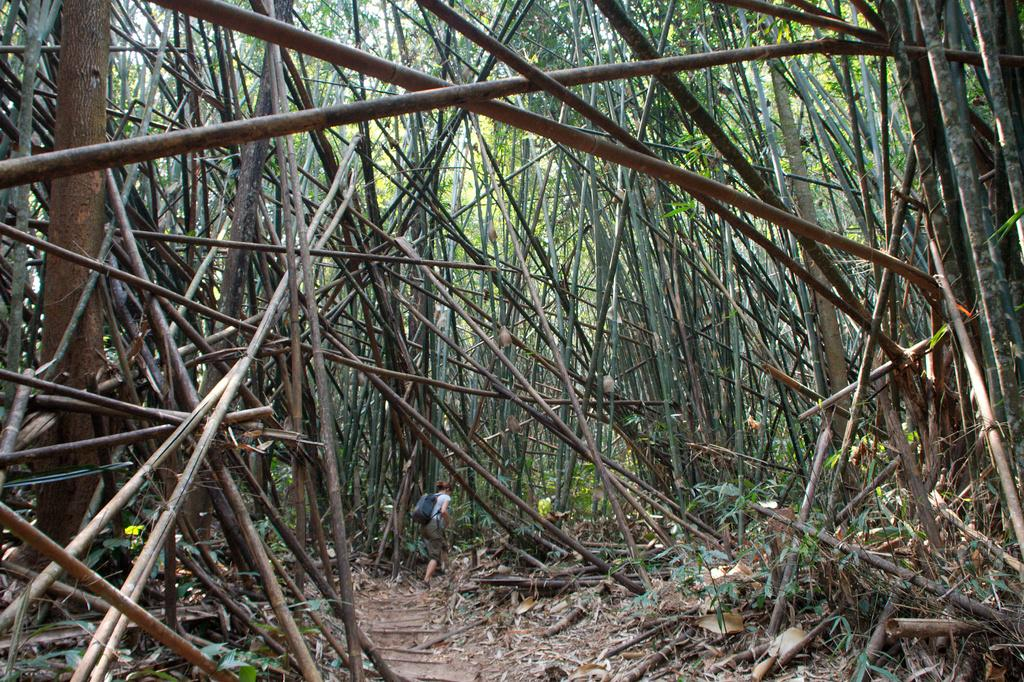What type of sticks are present in the image? There are dry bamboo sticks in the image. What other natural material can be seen in the image? There is dry grass in the image. Can you describe the woman's attire in the image? The woman is wearing a blue bag in the image. What can be seen in the background of the image? There are trees in the background of the image. What type of lumber is being traded in the image? There is no lumber or trade activity depicted in the image. How many cans of paint are visible in the image? There are no cans of paint present in the image. 